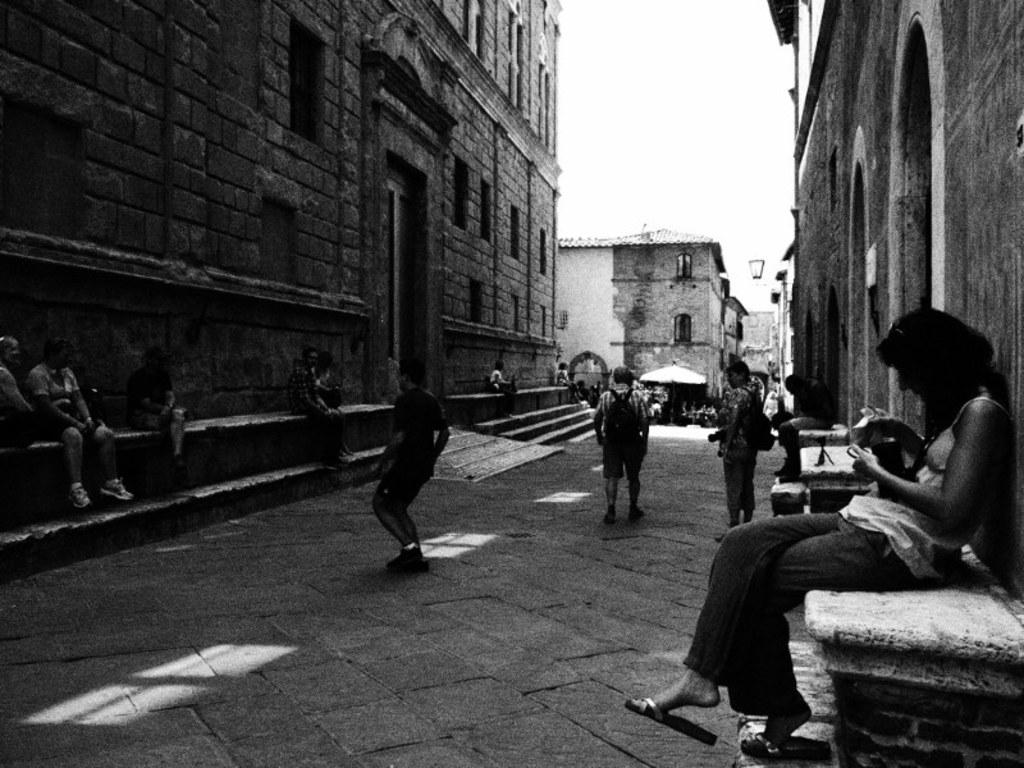What is the color scheme of the image? The image is black and white. What are the people in the image doing? There are persons sitting on a platform and persons on the road. What type of structures can be seen in the image? There are buildings in the image. What is visible in the background of the image? The sky is visible in the background of the image. What type of butter is being used to join the buildings together in the image? There is no butter or indication of joining in the image; it simply shows buildings and people in a black and white setting. 